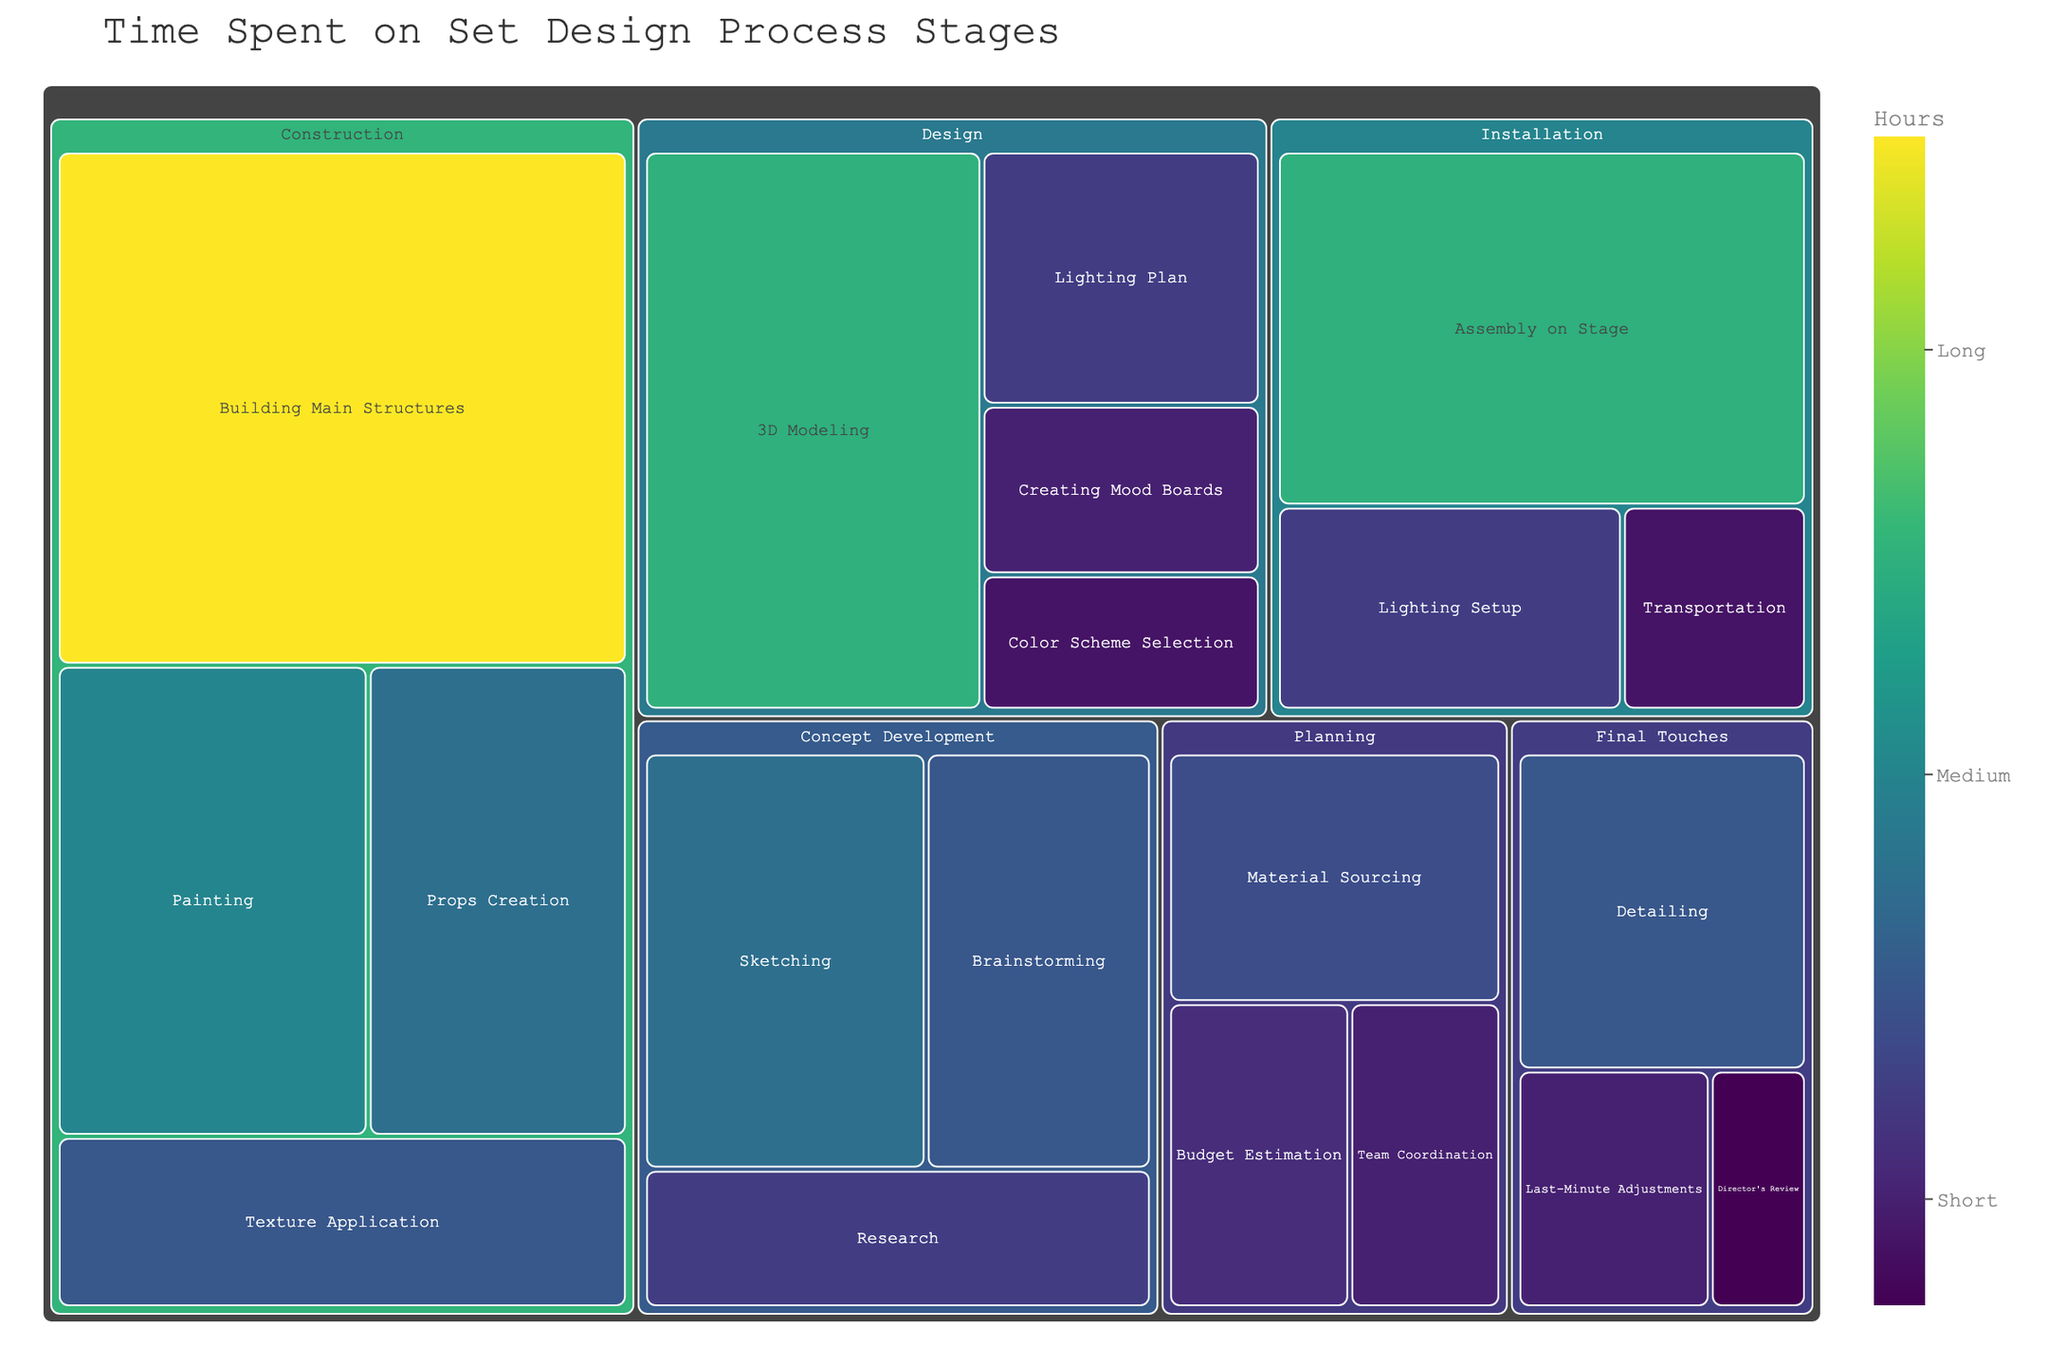what is the title of the treemap? The title of the treemap is usually at the top and gives an overall context of what the chart is showing. Here, the title can be seen at the top center of the chart.
Answer: Time Spent on Set Design Process Stages Which stage has the most hours spent on a single task? Identify the highest value in the treemap, which is colored distinctly due to the color scheme. This will direct us to the stage and the associated task.
Answer: Construction Which task within the Installation stage has the highest number of hours? Look specifically at the boxes labeled within the Installation stage and identify the one with the largest area or darkest color shade.
Answer: Assembly on Stage What is the total time spent on the Concept Development stage? Sum up the hours spent on Brainstorming, Research, and Sketching within the Concept Development stage.
Answer: 60 hours How many tasks are there in the Planning stage? Count the number of distinct boxes representing tasks within the Planning stage.
Answer: 3 tasks Which stage involves the least hours spent on a single task, and what is that task? Look for the smallest box or the lightest color within the entire treemap, and note the task and its stage.
Answer: Final Touches; Director's Review Compare the total hours spent on Construction and Design stages. Which one is greater and by how much? Sum up the hours for all tasks within the Construction stage and the Design stage separately; then compare the two sums and find the difference.
Answer: Construction; 90 hours more If you add the hours from Painting and Props Creation, how many hours are involved in these tasks? Find the hours spent on Painting and Props Creation within the Construction stage and sum them up.
Answer: 55 hours What can you infer about the importance of Lighting in the set design process? Look at the tasks related to lighting in various stages and sum their hours to understand the aggregate importance spent. Sum up the time for Lighting Plan and Lighting Setup.
Answer: 30 hours Which task in the Final Touches stage takes up the most hours? Look specifically at the boxes labeled within the Final Touches stage and identify the one with the largest area or darkest color shade.
Answer: Detailing 